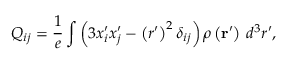<formula> <loc_0><loc_0><loc_500><loc_500>Q _ { i j } = { \frac { 1 } { e } } \int \left ( 3 x _ { i } ^ { \prime } x _ { j } ^ { \prime } - \left ( r ^ { \prime } \right ) ^ { 2 } \delta _ { i j } \right ) \rho \left ( r ^ { \prime } \right ) \, d ^ { 3 } r ^ { \prime } ,</formula> 